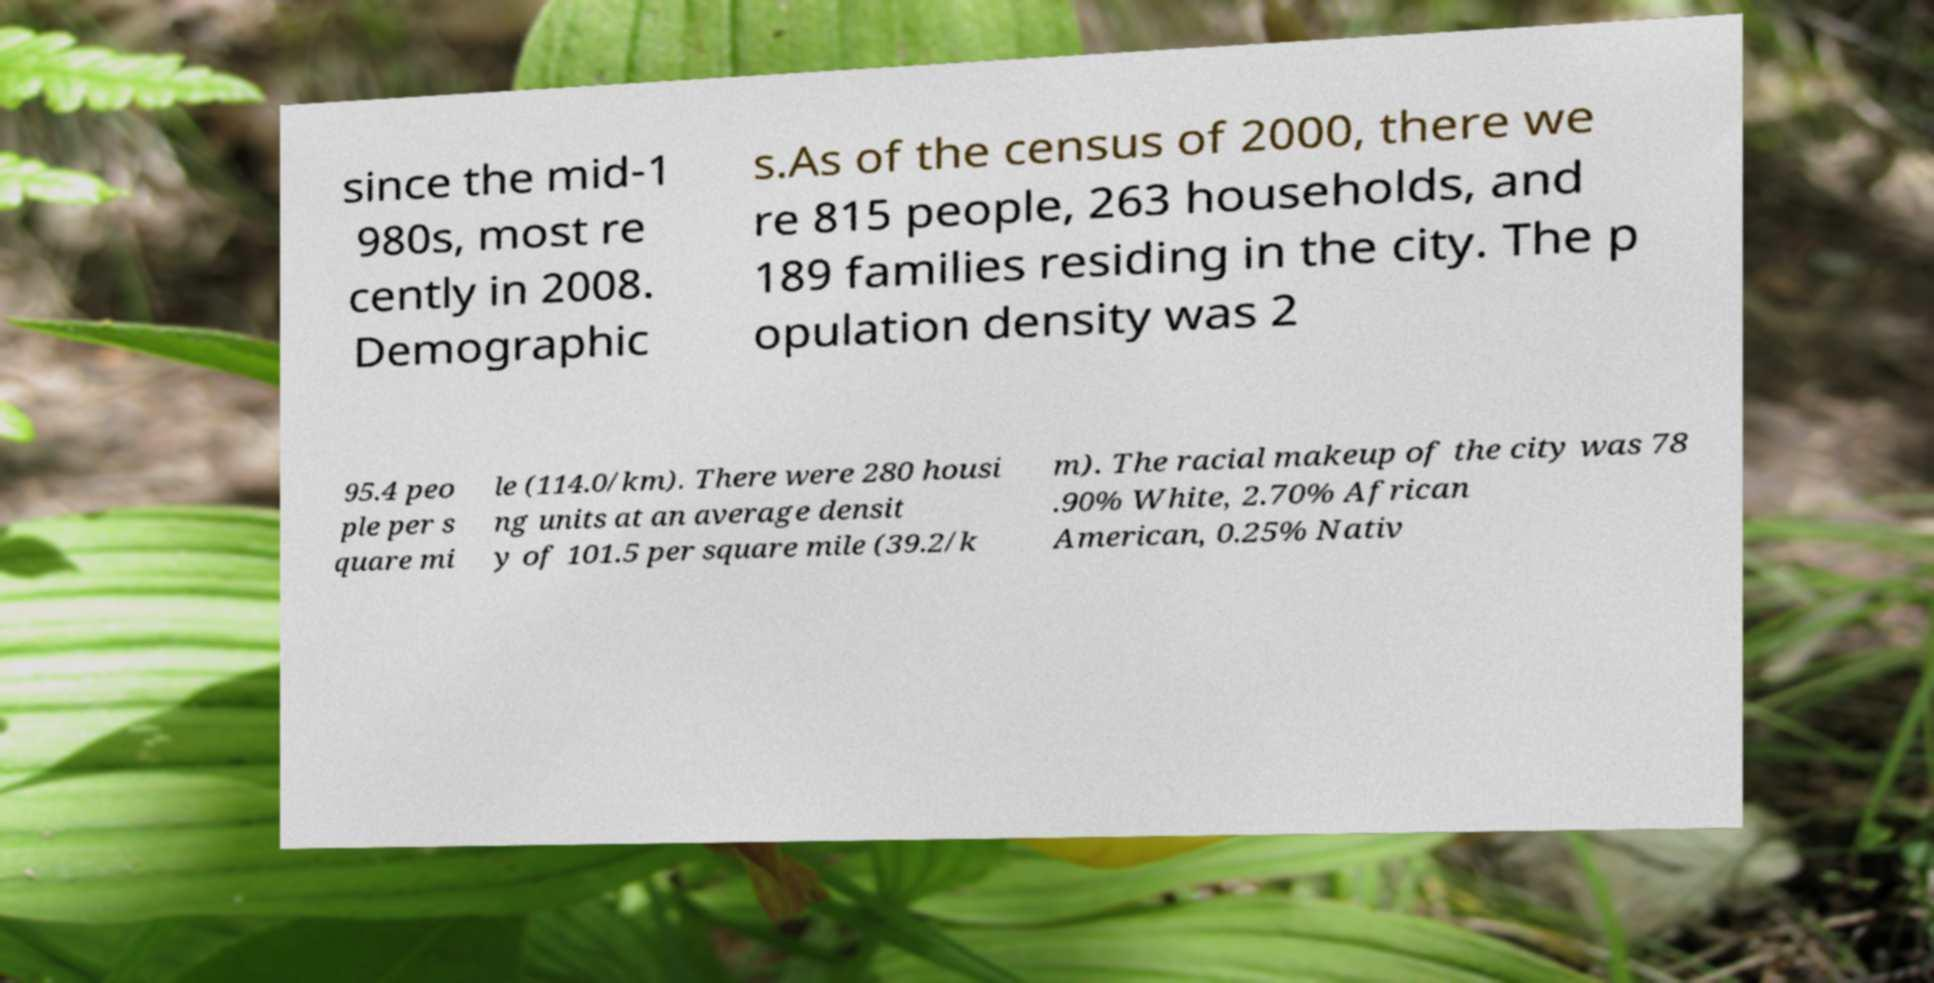For documentation purposes, I need the text within this image transcribed. Could you provide that? since the mid-1 980s, most re cently in 2008. Demographic s.As of the census of 2000, there we re 815 people, 263 households, and 189 families residing in the city. The p opulation density was 2 95.4 peo ple per s quare mi le (114.0/km). There were 280 housi ng units at an average densit y of 101.5 per square mile (39.2/k m). The racial makeup of the city was 78 .90% White, 2.70% African American, 0.25% Nativ 